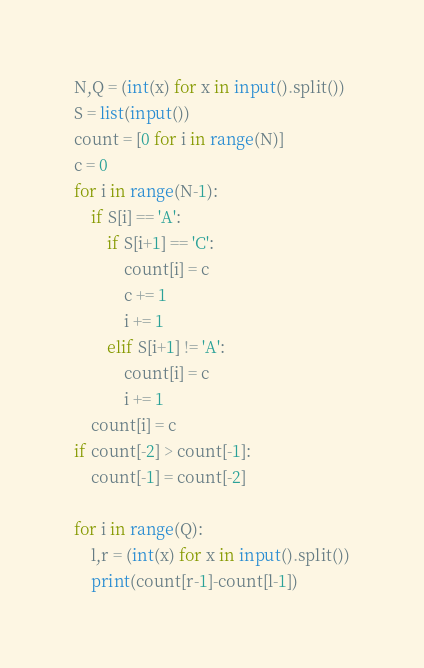Convert code to text. <code><loc_0><loc_0><loc_500><loc_500><_Python_>N,Q = (int(x) for x in input().split())
S = list(input())
count = [0 for i in range(N)]
c = 0
for i in range(N-1):
    if S[i] == 'A':
        if S[i+1] == 'C':
            count[i] = c
            c += 1
            i += 1
        elif S[i+1] != 'A':
            count[i] = c
            i += 1 
    count[i] = c
if count[-2] > count[-1]:
    count[-1] = count[-2]

for i in range(Q):
    l,r = (int(x) for x in input().split())
    print(count[r-1]-count[l-1])
</code> 